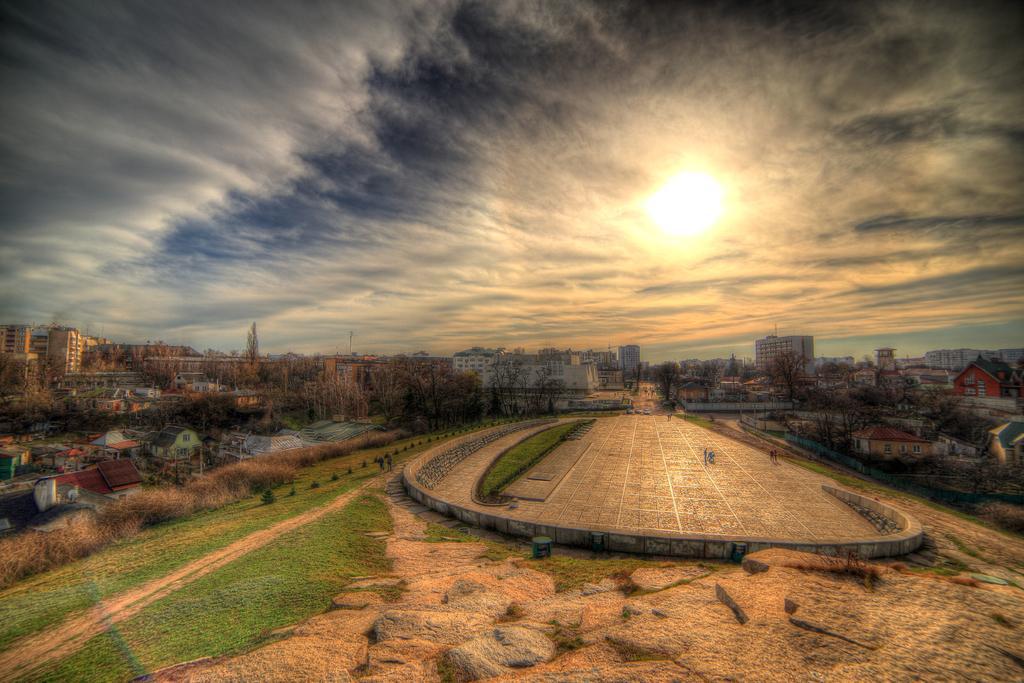Can you describe this image briefly? In this picture we can see few people, few houses, trees and buildings, and also we can find clouds. 